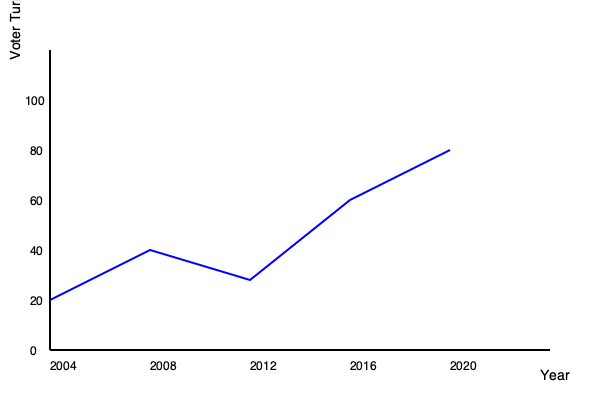The graph shows voter turnout trends in our jurisdiction over the past five presidential elections. What potential legislative actions could be proposed to address the trend observed between 2012 and 2020, and how might these actions impact future voter participation? To answer this question, we need to analyze the graph and consider potential legislative actions:

1. Observe the trend: The graph shows a significant increase in voter turnout from 2012 to 2020.

2. Identify possible factors:
   a. Increased political engagement
   b. Improved voting accessibility
   c. Enhanced voter education and outreach

3. Consider legislative actions:
   a. Expand early voting periods
   b. Implement automatic voter registration
   c. Increase funding for voter education programs
   d. Improve voting technology and infrastructure

4. Assess potential impacts:
   a. Expanded early voting could maintain or increase turnout by providing more flexibility for voters.
   b. Automatic voter registration could further increase participation by removing registration barriers.
   c. Enhanced voter education could lead to a more informed and engaged electorate.
   d. Improved voting technology could reduce wait times and increase confidence in the voting process.

5. Consider potential challenges:
   a. Budget constraints for implementing new programs
   b. Political opposition to certain reforms
   c. Ensuring election security with new technologies

6. Propose a balanced approach:
   Implement a combination of measures that address accessibility, education, and technology while considering budget constraints and maintaining election integrity.
Answer: Propose legislation to expand early voting, implement automatic voter registration, and increase funding for voter education, which could potentially maintain or further increase voter turnout by improving accessibility and engagement. 